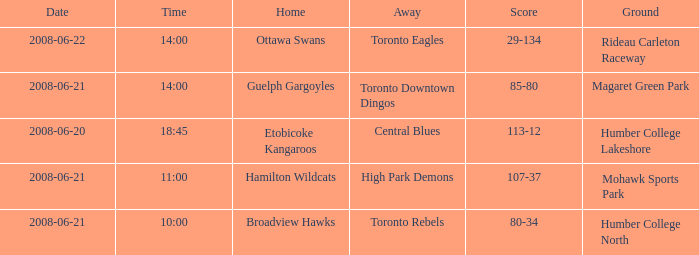What is the time on a ground that is humber college north? 10:00. 